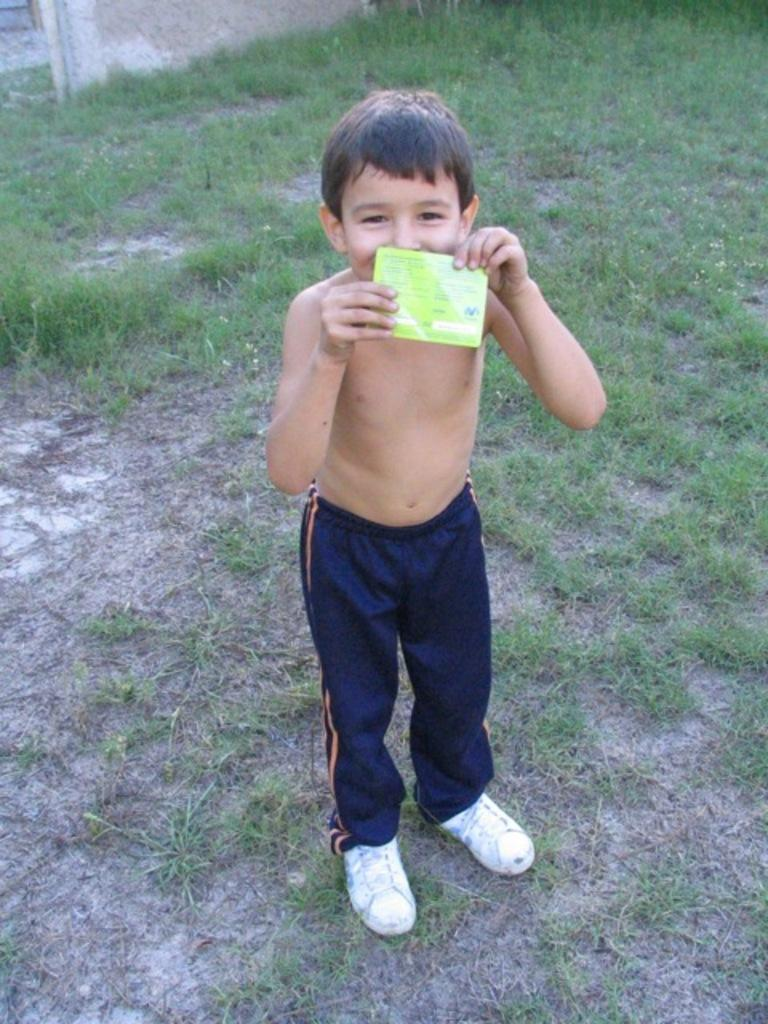What is the main subject of the image? There is a boy standing in the image. What is the boy holding in the image? The boy is holding an object. What type of vegetation can be seen in the image? There is green grass visible in the image. How many beggars can be seen in the image? There are no beggars present in the image; it features a boy standing and holding an object. What type of brush is the boy using to paint the market in the image? There is no brush or market present in the image; it only shows a boy standing and holding an object. 